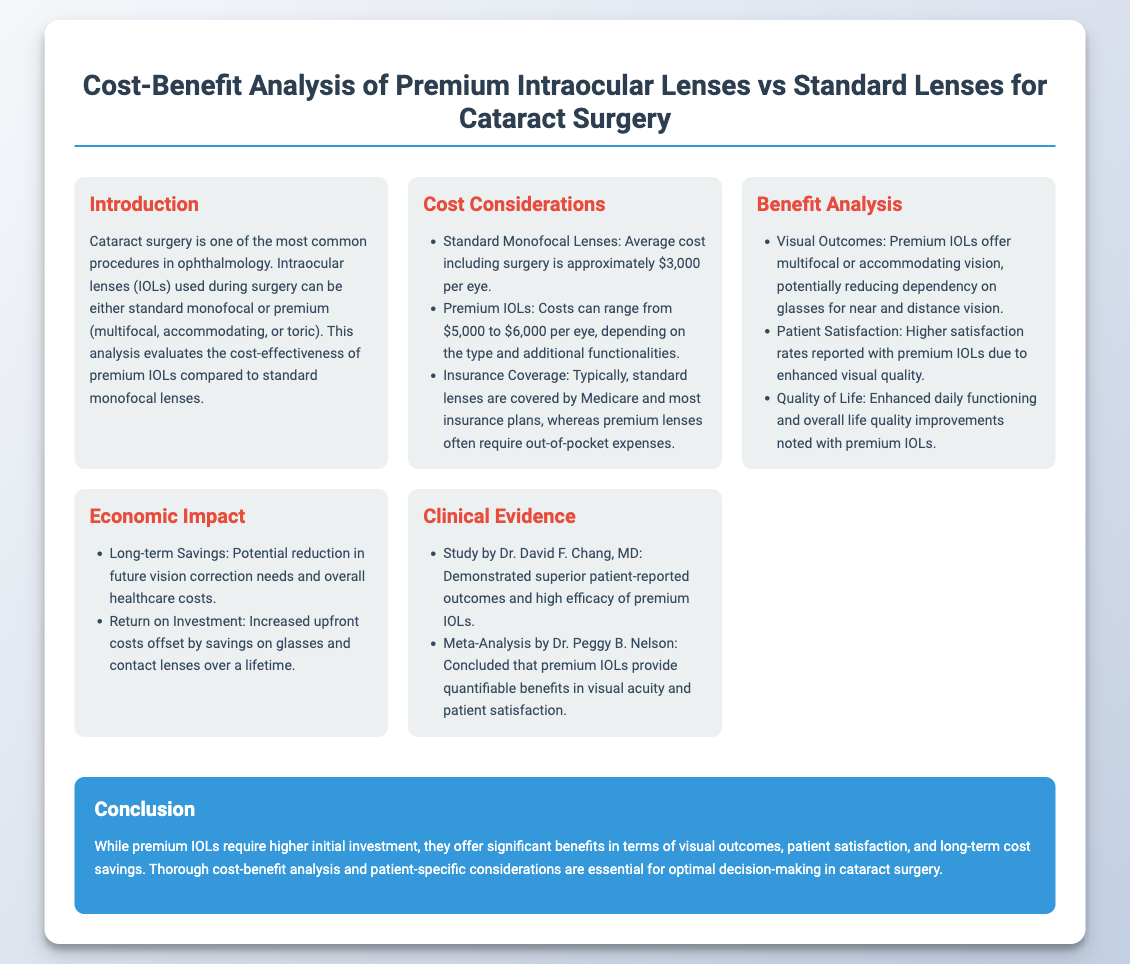what is the average cost of standard monofocal lenses? The document states that the average cost for standard monofocal lenses is approximately $3,000 per eye.
Answer: $3,000 what is the cost range for premium IOLs? The document mentions that the costs for premium IOLs can range from $5,000 to $6,000 per eye.
Answer: $5,000 to $6,000 what is a key benefit of premium IOLs? The document lists that premium IOLs offer multifocal or accommodating vision, potentially reducing dependency on glasses for near and distance vision.
Answer: Multifocal or accommodating vision who conducted a study demonstrating superior outcomes for premium IOLs? The document cites Dr. David F. Chang, MD as the one who conducted a study demonstrating superior outcomes.
Answer: Dr. David F. Chang, MD what is one reason for long-term savings associated with premium IOLs? One reason mentioned in the document is the potential reduction in future vision correction needs and overall healthcare costs.
Answer: Reduction in future vision correction needs which lens type is typically covered by Medicare? The document states that standard lenses are typically covered by Medicare and most insurance plans.
Answer: Standard lenses how do premium IOLs impact patient satisfaction? According to the document, higher satisfaction rates are reported with premium IOLs due to enhanced visual quality.
Answer: Higher satisfaction rates what is a primary consideration when deciding on lens type for cataract surgery? The document emphasizes that thorough cost-benefit analysis and patient-specific considerations are essential for optimal decision-making.
Answer: Patient-specific considerations 